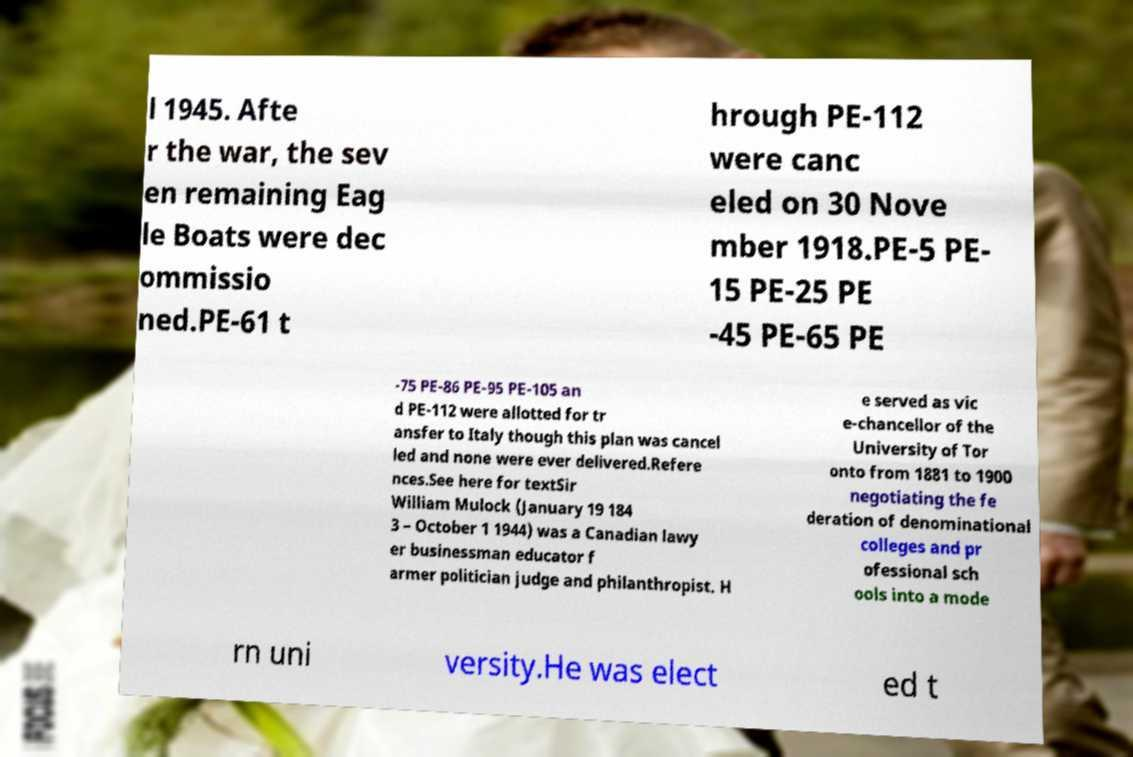Can you read and provide the text displayed in the image?This photo seems to have some interesting text. Can you extract and type it out for me? l 1945. Afte r the war, the sev en remaining Eag le Boats were dec ommissio ned.PE-61 t hrough PE-112 were canc eled on 30 Nove mber 1918.PE-5 PE- 15 PE-25 PE -45 PE-65 PE -75 PE-86 PE-95 PE-105 an d PE-112 were allotted for tr ansfer to Italy though this plan was cancel led and none were ever delivered.Refere nces.See here for textSir William Mulock (January 19 184 3 – October 1 1944) was a Canadian lawy er businessman educator f armer politician judge and philanthropist. H e served as vic e-chancellor of the University of Tor onto from 1881 to 1900 negotiating the fe deration of denominational colleges and pr ofessional sch ools into a mode rn uni versity.He was elect ed t 